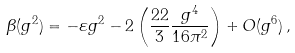Convert formula to latex. <formula><loc_0><loc_0><loc_500><loc_500>\beta ( g ^ { 2 } ) = - \varepsilon g ^ { 2 } - 2 \left ( \frac { 2 2 } { 3 } \frac { g ^ { 4 } } { 1 6 \pi ^ { 2 } } \right ) + O ( g ^ { 6 } ) \, ,</formula> 